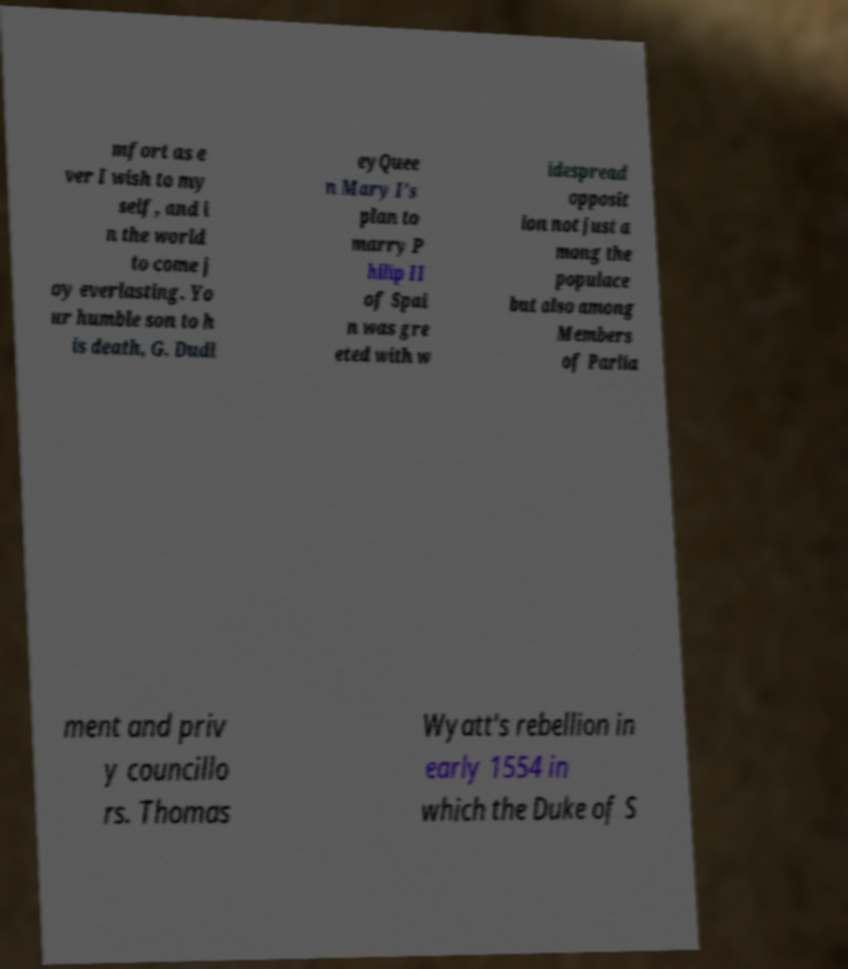Could you extract and type out the text from this image? mfort as e ver I wish to my self, and i n the world to come j oy everlasting. Yo ur humble son to h is death, G. Dudl eyQuee n Mary I's plan to marry P hilip II of Spai n was gre eted with w idespread opposit ion not just a mong the populace but also among Members of Parlia ment and priv y councillo rs. Thomas Wyatt's rebellion in early 1554 in which the Duke of S 